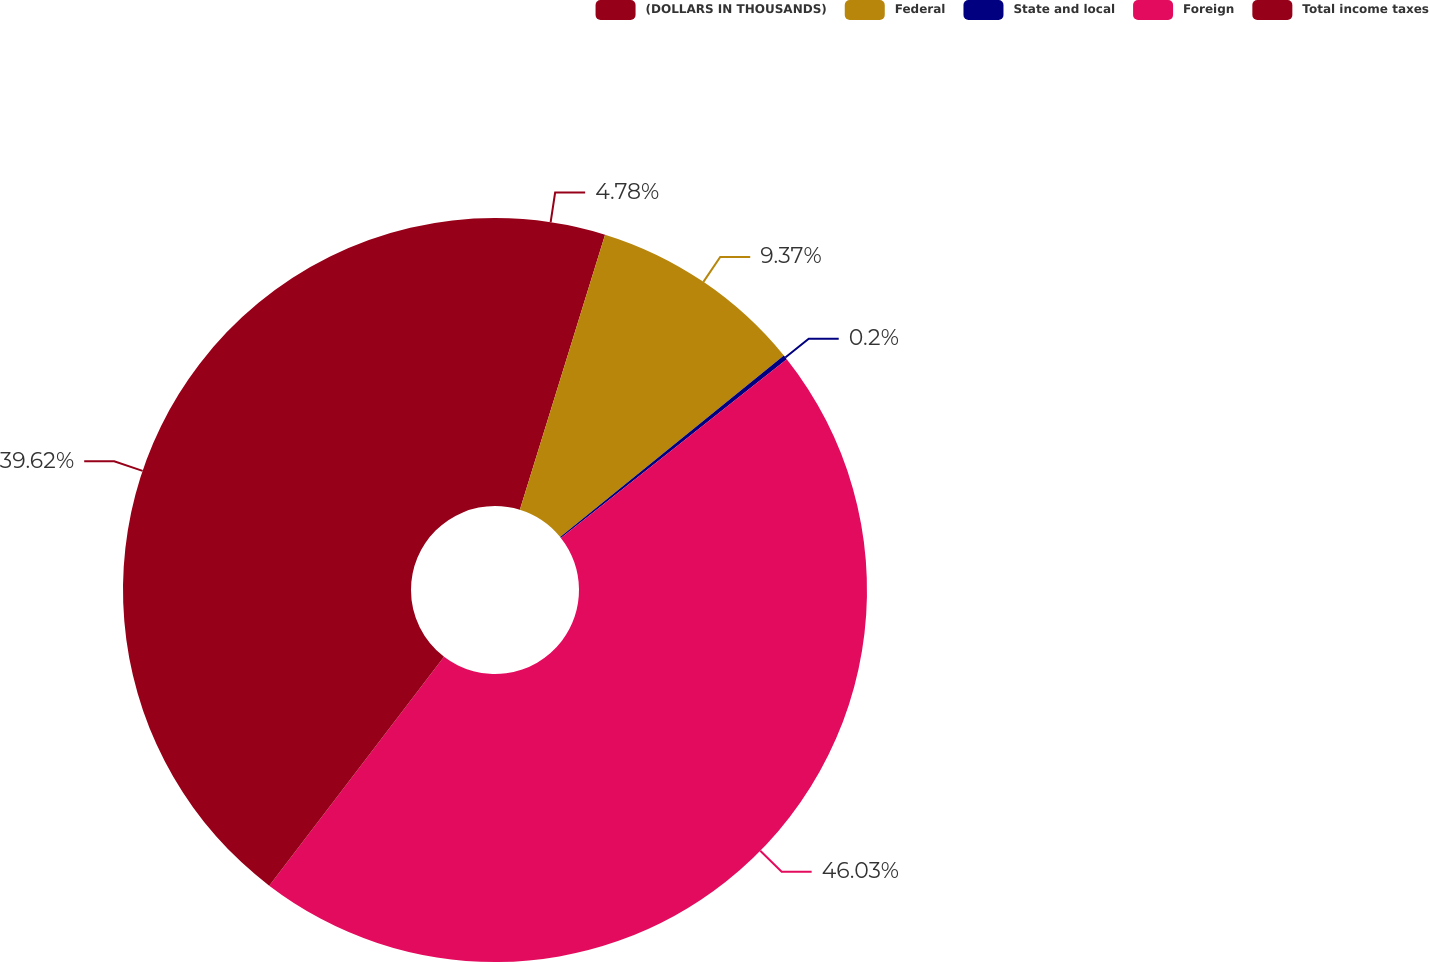Convert chart. <chart><loc_0><loc_0><loc_500><loc_500><pie_chart><fcel>(DOLLARS IN THOUSANDS)<fcel>Federal<fcel>State and local<fcel>Foreign<fcel>Total income taxes<nl><fcel>4.78%<fcel>9.37%<fcel>0.2%<fcel>46.03%<fcel>39.62%<nl></chart> 